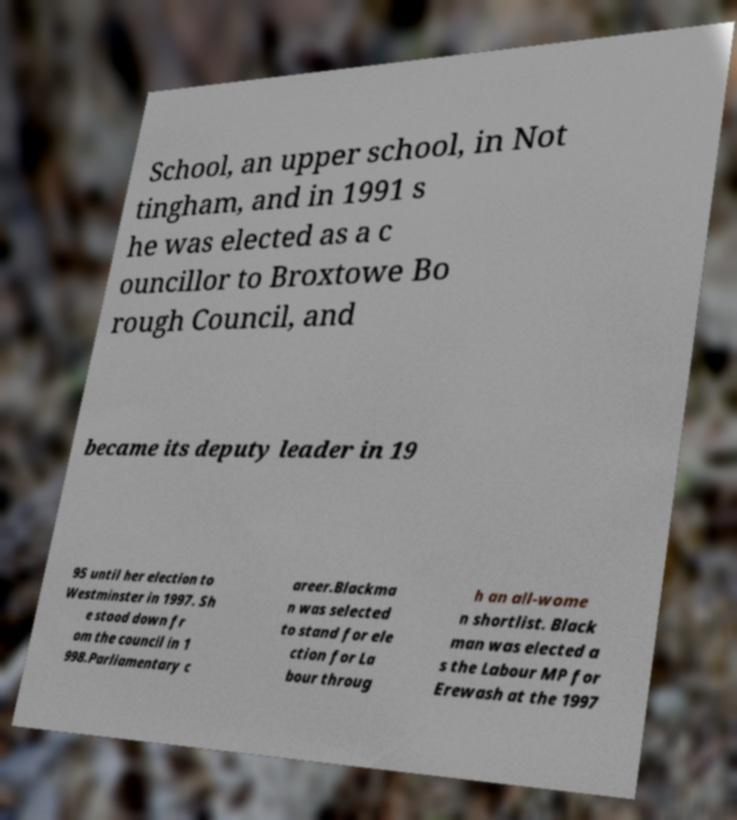Could you assist in decoding the text presented in this image and type it out clearly? School, an upper school, in Not tingham, and in 1991 s he was elected as a c ouncillor to Broxtowe Bo rough Council, and became its deputy leader in 19 95 until her election to Westminster in 1997. Sh e stood down fr om the council in 1 998.Parliamentary c areer.Blackma n was selected to stand for ele ction for La bour throug h an all-wome n shortlist. Black man was elected a s the Labour MP for Erewash at the 1997 